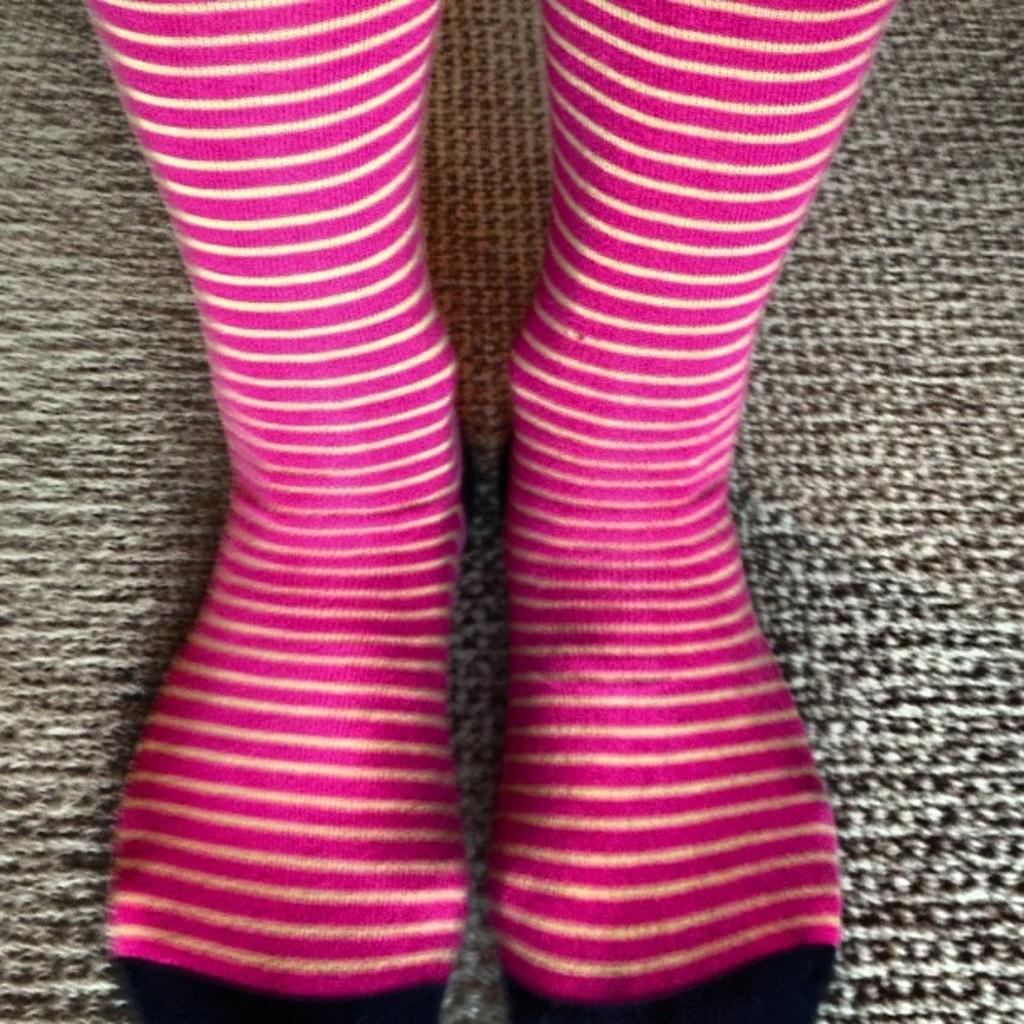Could you give a brief overview of what you see in this image? In this image there is a mat, on that mat there are legs wearing socks. 